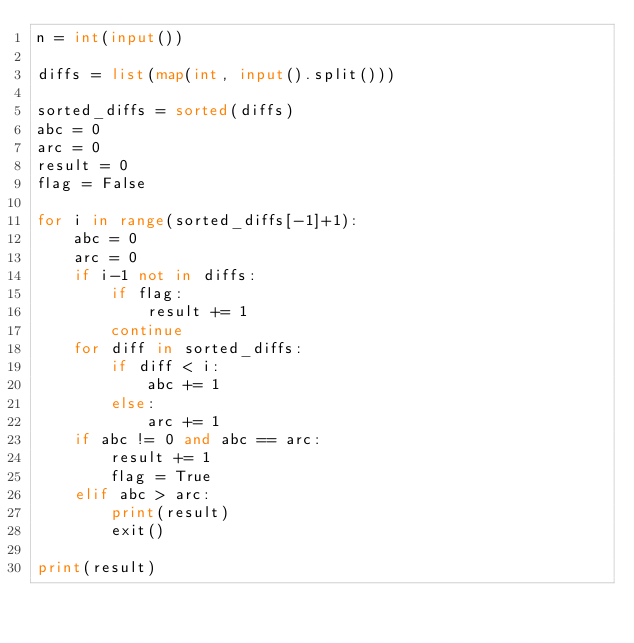<code> <loc_0><loc_0><loc_500><loc_500><_Python_>n = int(input())

diffs = list(map(int, input().split()))

sorted_diffs = sorted(diffs)
abc = 0
arc = 0
result = 0
flag = False

for i in range(sorted_diffs[-1]+1):
    abc = 0
    arc = 0
    if i-1 not in diffs:
        if flag:
            result += 1
        continue
    for diff in sorted_diffs:
        if diff < i:
            abc += 1
        else:
            arc += 1
    if abc != 0 and abc == arc:
        result += 1
        flag = True
    elif abc > arc:
        print(result)
        exit()

print(result)
</code> 